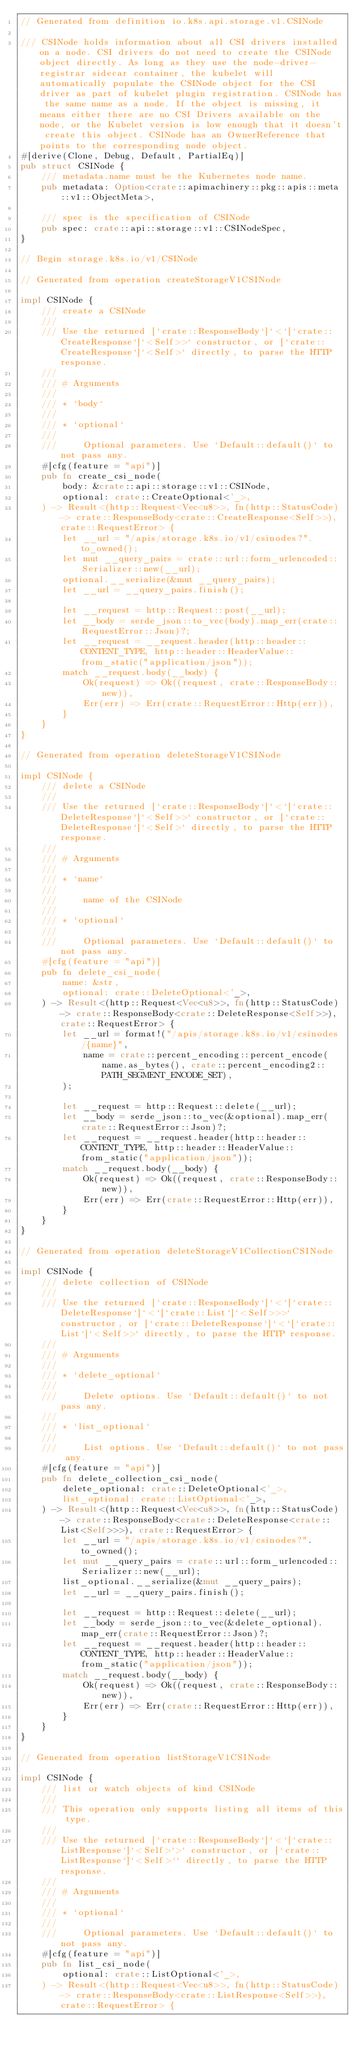<code> <loc_0><loc_0><loc_500><loc_500><_Rust_>// Generated from definition io.k8s.api.storage.v1.CSINode

/// CSINode holds information about all CSI drivers installed on a node. CSI drivers do not need to create the CSINode object directly. As long as they use the node-driver-registrar sidecar container, the kubelet will automatically populate the CSINode object for the CSI driver as part of kubelet plugin registration. CSINode has the same name as a node. If the object is missing, it means either there are no CSI Drivers available on the node, or the Kubelet version is low enough that it doesn't create this object. CSINode has an OwnerReference that points to the corresponding node object.
#[derive(Clone, Debug, Default, PartialEq)]
pub struct CSINode {
    /// metadata.name must be the Kubernetes node name.
    pub metadata: Option<crate::apimachinery::pkg::apis::meta::v1::ObjectMeta>,

    /// spec is the specification of CSINode
    pub spec: crate::api::storage::v1::CSINodeSpec,
}

// Begin storage.k8s.io/v1/CSINode

// Generated from operation createStorageV1CSINode

impl CSINode {
    /// create a CSINode
    ///
    /// Use the returned [`crate::ResponseBody`]`<`[`crate::CreateResponse`]`<Self>>` constructor, or [`crate::CreateResponse`]`<Self>` directly, to parse the HTTP response.
    ///
    /// # Arguments
    ///
    /// * `body`
    ///
    /// * `optional`
    ///
    ///     Optional parameters. Use `Default::default()` to not pass any.
    #[cfg(feature = "api")]
    pub fn create_csi_node(
        body: &crate::api::storage::v1::CSINode,
        optional: crate::CreateOptional<'_>,
    ) -> Result<(http::Request<Vec<u8>>, fn(http::StatusCode) -> crate::ResponseBody<crate::CreateResponse<Self>>), crate::RequestError> {
        let __url = "/apis/storage.k8s.io/v1/csinodes?".to_owned();
        let mut __query_pairs = crate::url::form_urlencoded::Serializer::new(__url);
        optional.__serialize(&mut __query_pairs);
        let __url = __query_pairs.finish();

        let __request = http::Request::post(__url);
        let __body = serde_json::to_vec(body).map_err(crate::RequestError::Json)?;
        let __request = __request.header(http::header::CONTENT_TYPE, http::header::HeaderValue::from_static("application/json"));
        match __request.body(__body) {
            Ok(request) => Ok((request, crate::ResponseBody::new)),
            Err(err) => Err(crate::RequestError::Http(err)),
        }
    }
}

// Generated from operation deleteStorageV1CSINode

impl CSINode {
    /// delete a CSINode
    ///
    /// Use the returned [`crate::ResponseBody`]`<`[`crate::DeleteResponse`]`<Self>>` constructor, or [`crate::DeleteResponse`]`<Self>` directly, to parse the HTTP response.
    ///
    /// # Arguments
    ///
    /// * `name`
    ///
    ///     name of the CSINode
    ///
    /// * `optional`
    ///
    ///     Optional parameters. Use `Default::default()` to not pass any.
    #[cfg(feature = "api")]
    pub fn delete_csi_node(
        name: &str,
        optional: crate::DeleteOptional<'_>,
    ) -> Result<(http::Request<Vec<u8>>, fn(http::StatusCode) -> crate::ResponseBody<crate::DeleteResponse<Self>>), crate::RequestError> {
        let __url = format!("/apis/storage.k8s.io/v1/csinodes/{name}",
            name = crate::percent_encoding::percent_encode(name.as_bytes(), crate::percent_encoding2::PATH_SEGMENT_ENCODE_SET),
        );

        let __request = http::Request::delete(__url);
        let __body = serde_json::to_vec(&optional).map_err(crate::RequestError::Json)?;
        let __request = __request.header(http::header::CONTENT_TYPE, http::header::HeaderValue::from_static("application/json"));
        match __request.body(__body) {
            Ok(request) => Ok((request, crate::ResponseBody::new)),
            Err(err) => Err(crate::RequestError::Http(err)),
        }
    }
}

// Generated from operation deleteStorageV1CollectionCSINode

impl CSINode {
    /// delete collection of CSINode
    ///
    /// Use the returned [`crate::ResponseBody`]`<`[`crate::DeleteResponse`]`<`[`crate::List`]`<Self>>>` constructor, or [`crate::DeleteResponse`]`<`[`crate::List`]`<Self>>` directly, to parse the HTTP response.
    ///
    /// # Arguments
    ///
    /// * `delete_optional`
    ///
    ///     Delete options. Use `Default::default()` to not pass any.
    ///
    /// * `list_optional`
    ///
    ///     List options. Use `Default::default()` to not pass any.
    #[cfg(feature = "api")]
    pub fn delete_collection_csi_node(
        delete_optional: crate::DeleteOptional<'_>,
        list_optional: crate::ListOptional<'_>,
    ) -> Result<(http::Request<Vec<u8>>, fn(http::StatusCode) -> crate::ResponseBody<crate::DeleteResponse<crate::List<Self>>>), crate::RequestError> {
        let __url = "/apis/storage.k8s.io/v1/csinodes?".to_owned();
        let mut __query_pairs = crate::url::form_urlencoded::Serializer::new(__url);
        list_optional.__serialize(&mut __query_pairs);
        let __url = __query_pairs.finish();

        let __request = http::Request::delete(__url);
        let __body = serde_json::to_vec(&delete_optional).map_err(crate::RequestError::Json)?;
        let __request = __request.header(http::header::CONTENT_TYPE, http::header::HeaderValue::from_static("application/json"));
        match __request.body(__body) {
            Ok(request) => Ok((request, crate::ResponseBody::new)),
            Err(err) => Err(crate::RequestError::Http(err)),
        }
    }
}

// Generated from operation listStorageV1CSINode

impl CSINode {
    /// list or watch objects of kind CSINode
    ///
    /// This operation only supports listing all items of this type.
    ///
    /// Use the returned [`crate::ResponseBody`]`<`[`crate::ListResponse`]`<Self>`>` constructor, or [`crate::ListResponse`]`<Self>`` directly, to parse the HTTP response.
    ///
    /// # Arguments
    ///
    /// * `optional`
    ///
    ///     Optional parameters. Use `Default::default()` to not pass any.
    #[cfg(feature = "api")]
    pub fn list_csi_node(
        optional: crate::ListOptional<'_>,
    ) -> Result<(http::Request<Vec<u8>>, fn(http::StatusCode) -> crate::ResponseBody<crate::ListResponse<Self>>), crate::RequestError> {</code> 